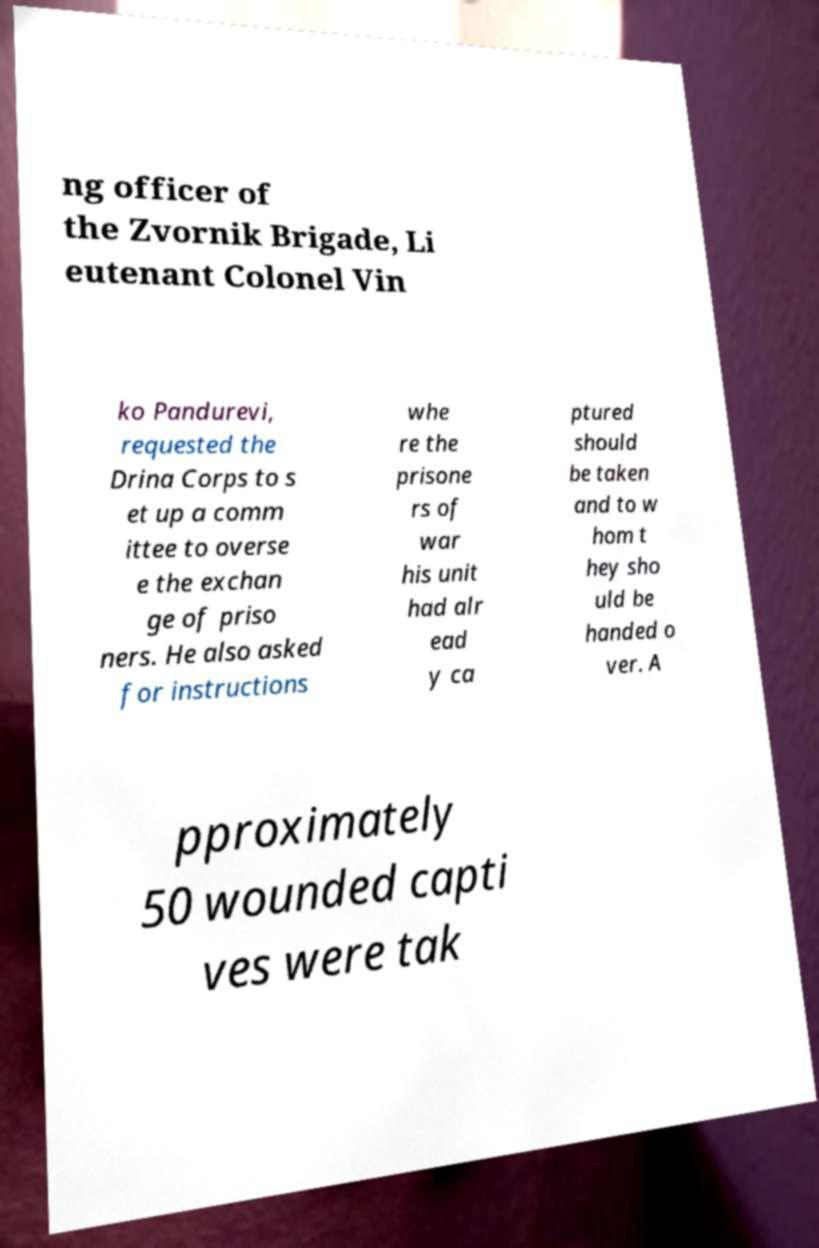Please read and relay the text visible in this image. What does it say? ng officer of the Zvornik Brigade, Li eutenant Colonel Vin ko Pandurevi, requested the Drina Corps to s et up a comm ittee to overse e the exchan ge of priso ners. He also asked for instructions whe re the prisone rs of war his unit had alr ead y ca ptured should be taken and to w hom t hey sho uld be handed o ver. A pproximately 50 wounded capti ves were tak 